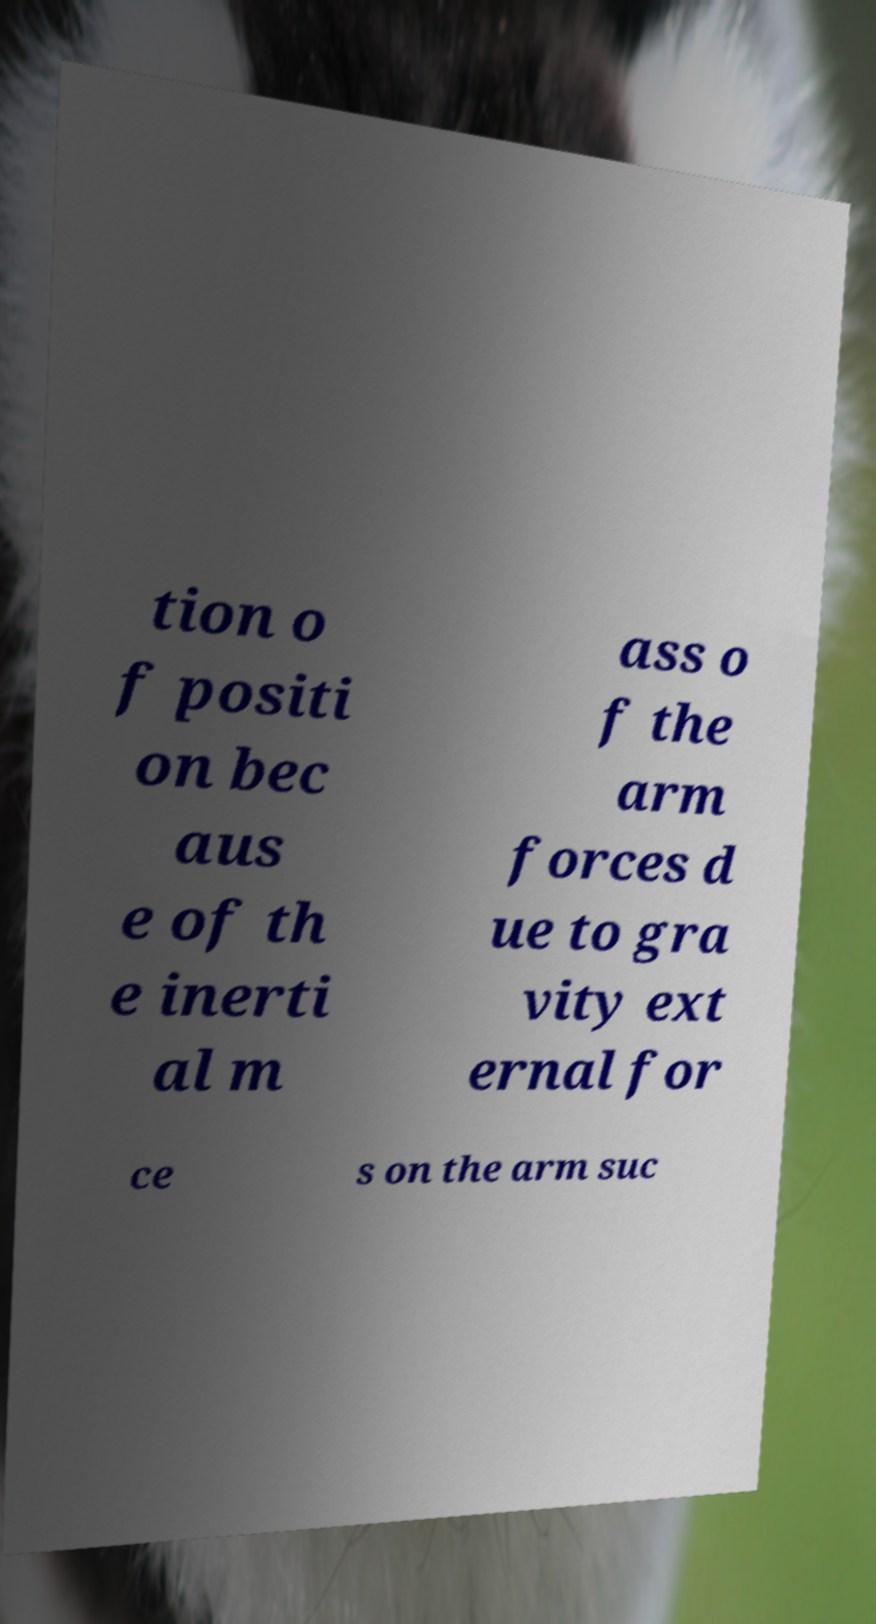Can you accurately transcribe the text from the provided image for me? tion o f positi on bec aus e of th e inerti al m ass o f the arm forces d ue to gra vity ext ernal for ce s on the arm suc 